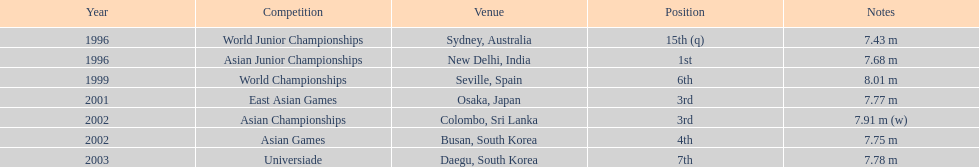Parse the full table. {'header': ['Year', 'Competition', 'Venue', 'Position', 'Notes'], 'rows': [['1996', 'World Junior Championships', 'Sydney, Australia', '15th (q)', '7.43 m'], ['1996', 'Asian Junior Championships', 'New Delhi, India', '1st', '7.68 m'], ['1999', 'World Championships', 'Seville, Spain', '6th', '8.01 m'], ['2001', 'East Asian Games', 'Osaka, Japan', '3rd', '7.77 m'], ['2002', 'Asian Championships', 'Colombo, Sri Lanka', '3rd', '7.91 m (w)'], ['2002', 'Asian Games', 'Busan, South Korea', '4th', '7.75 m'], ['2003', 'Universiade', 'Daegu, South Korea', '7th', '7.78 m']]} In what single tournament did this contender reach the first place? Asian Junior Championships. 